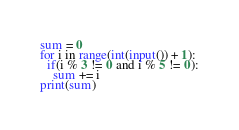Convert code to text. <code><loc_0><loc_0><loc_500><loc_500><_Python_>sum = 0
for i in range(int(input()) + 1):
  if(i % 3 != 0 and i % 5 != 0):
    sum += i
print(sum)</code> 